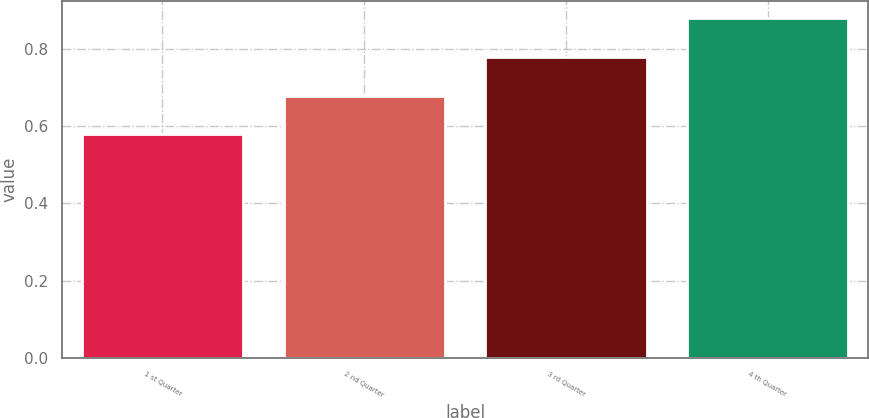Convert chart. <chart><loc_0><loc_0><loc_500><loc_500><bar_chart><fcel>1 st Quarter<fcel>2 nd Quarter<fcel>3 rd Quarter<fcel>4 th Quarter<nl><fcel>0.58<fcel>0.68<fcel>0.78<fcel>0.88<nl></chart> 